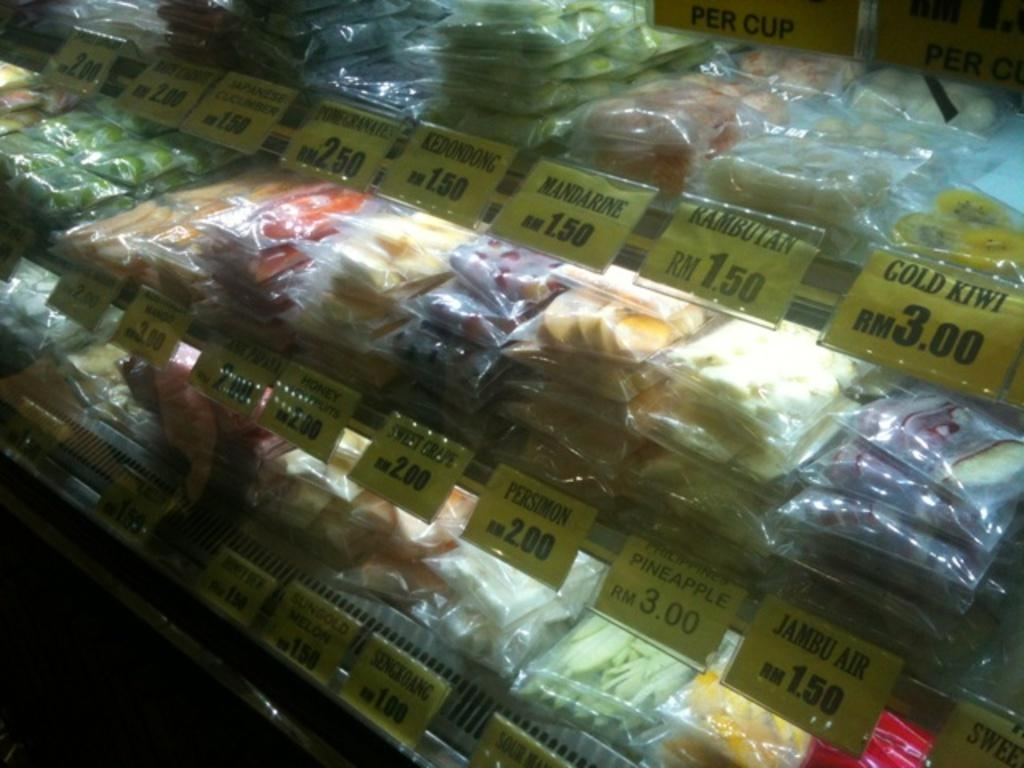What is the arrangement of the food in the image? The food is packed in covers and placed in a rack. Can you describe the type of containers used for the food? The food is packed in covers, which are likely used to keep the food fresh and organized. What type of tree can be seen growing in the image? There is no tree present in the image; it only shows food packed in covers and placed in a rack. 